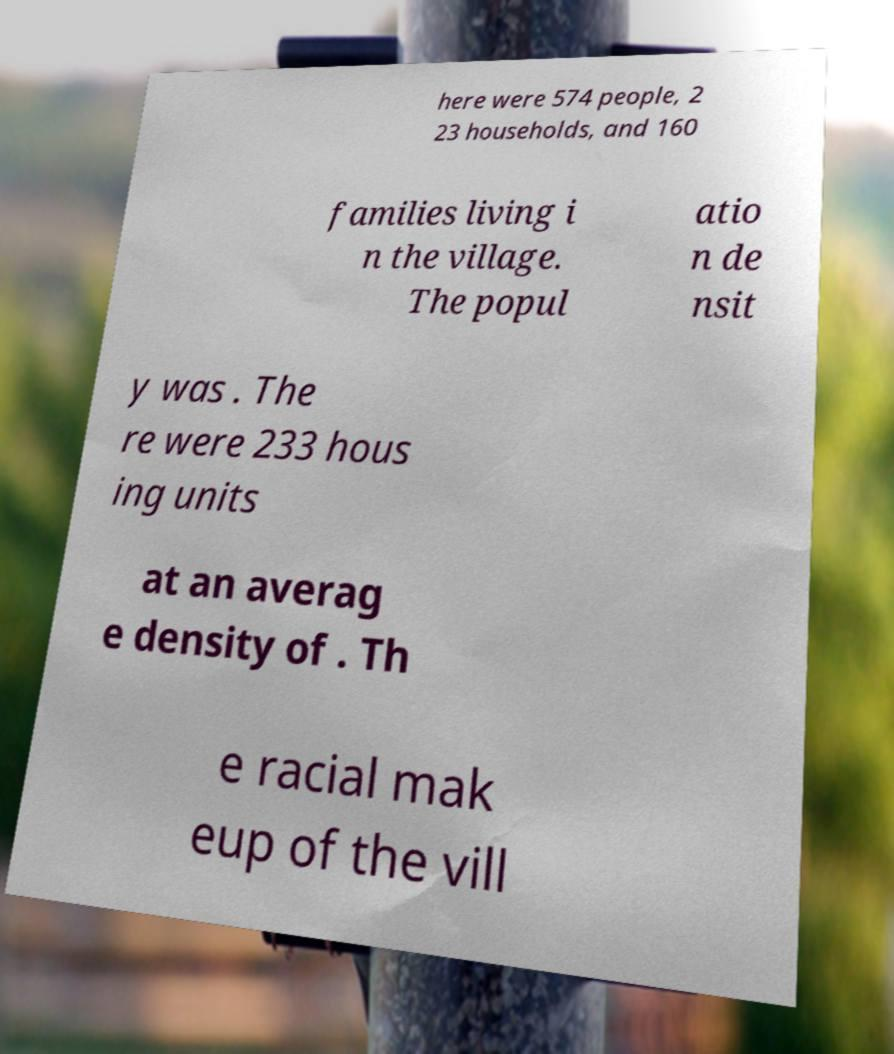For documentation purposes, I need the text within this image transcribed. Could you provide that? here were 574 people, 2 23 households, and 160 families living i n the village. The popul atio n de nsit y was . The re were 233 hous ing units at an averag e density of . Th e racial mak eup of the vill 